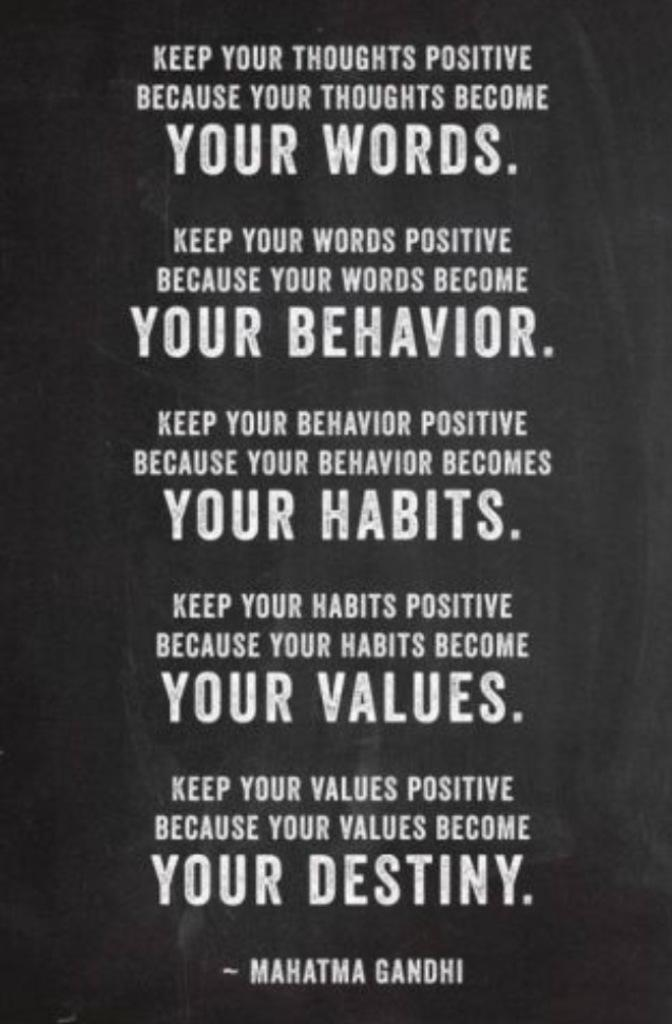<image>
Share a concise interpretation of the image provided. A motivational quote from Mahatma Gandhi about being positive. 